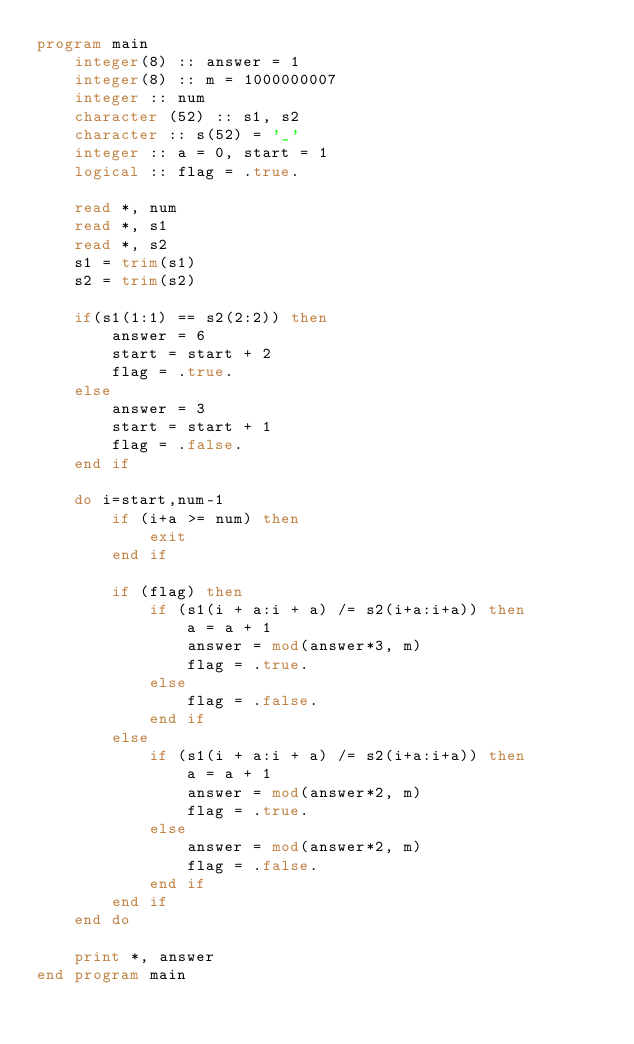Convert code to text. <code><loc_0><loc_0><loc_500><loc_500><_FORTRAN_>program main
    integer(8) :: answer = 1
    integer(8) :: m = 1000000007
    integer :: num
    character (52) :: s1, s2
    character :: s(52) = '_'
    integer :: a = 0, start = 1
    logical :: flag = .true.

    read *, num
    read *, s1
    read *, s2
    s1 = trim(s1)
    s2 = trim(s2)

    if(s1(1:1) == s2(2:2)) then
        answer = 6
        start = start + 2
        flag = .true.
    else
        answer = 3
        start = start + 1
        flag = .false.
    end if

    do i=start,num-1
        if (i+a >= num) then
            exit
        end if

        if (flag) then
            if (s1(i + a:i + a) /= s2(i+a:i+a)) then
                a = a + 1
                answer = mod(answer*3, m)
                flag = .true.
            else
                flag = .false.
            end if
        else
            if (s1(i + a:i + a) /= s2(i+a:i+a)) then
                a = a + 1
                answer = mod(answer*2, m)
                flag = .true.
            else
                answer = mod(answer*2, m)
                flag = .false.
            end if
        end if
    end do

    print *, answer
end program main</code> 